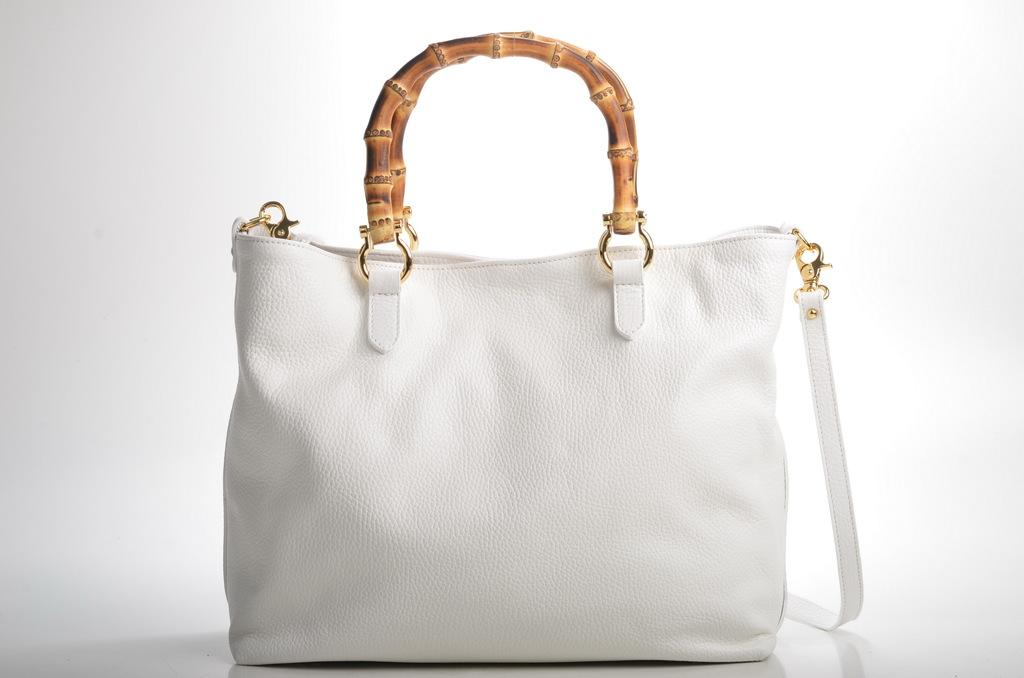What color is the handbag in the image? The handbag in the image is white. How many ladybugs are crawling on the handbag in the image? There are no ladybugs present in the image; it only features a white color handbag. 